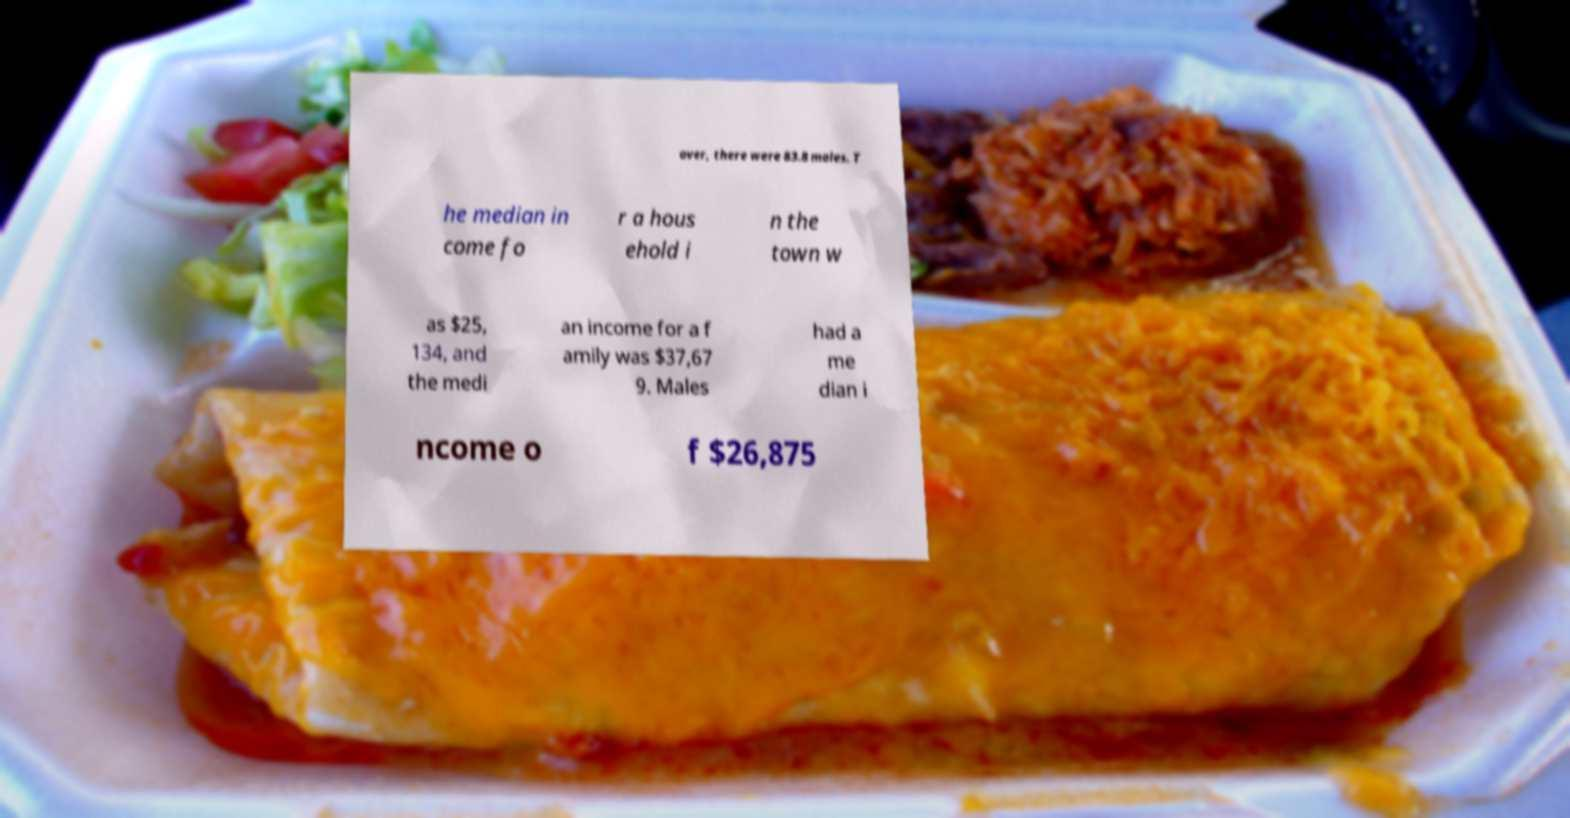Can you accurately transcribe the text from the provided image for me? over, there were 83.8 males. T he median in come fo r a hous ehold i n the town w as $25, 134, and the medi an income for a f amily was $37,67 9. Males had a me dian i ncome o f $26,875 